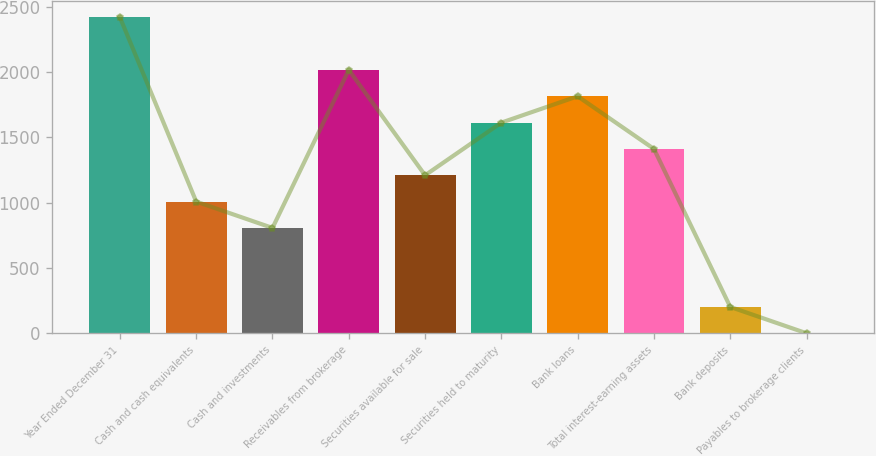Convert chart to OTSL. <chart><loc_0><loc_0><loc_500><loc_500><bar_chart><fcel>Year Ended December 31<fcel>Cash and cash equivalents<fcel>Cash and investments<fcel>Receivables from brokerage<fcel>Securities available for sale<fcel>Securities held to maturity<fcel>Bank loans<fcel>Total interest-earning assets<fcel>Bank deposits<fcel>Payables to brokerage clients<nl><fcel>2418.01<fcel>1007.51<fcel>806.01<fcel>2015.01<fcel>1209.01<fcel>1612.01<fcel>1813.51<fcel>1410.51<fcel>201.51<fcel>0.01<nl></chart> 